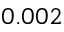Convert formula to latex. <formula><loc_0><loc_0><loc_500><loc_500>0 . 0 0 2</formula> 